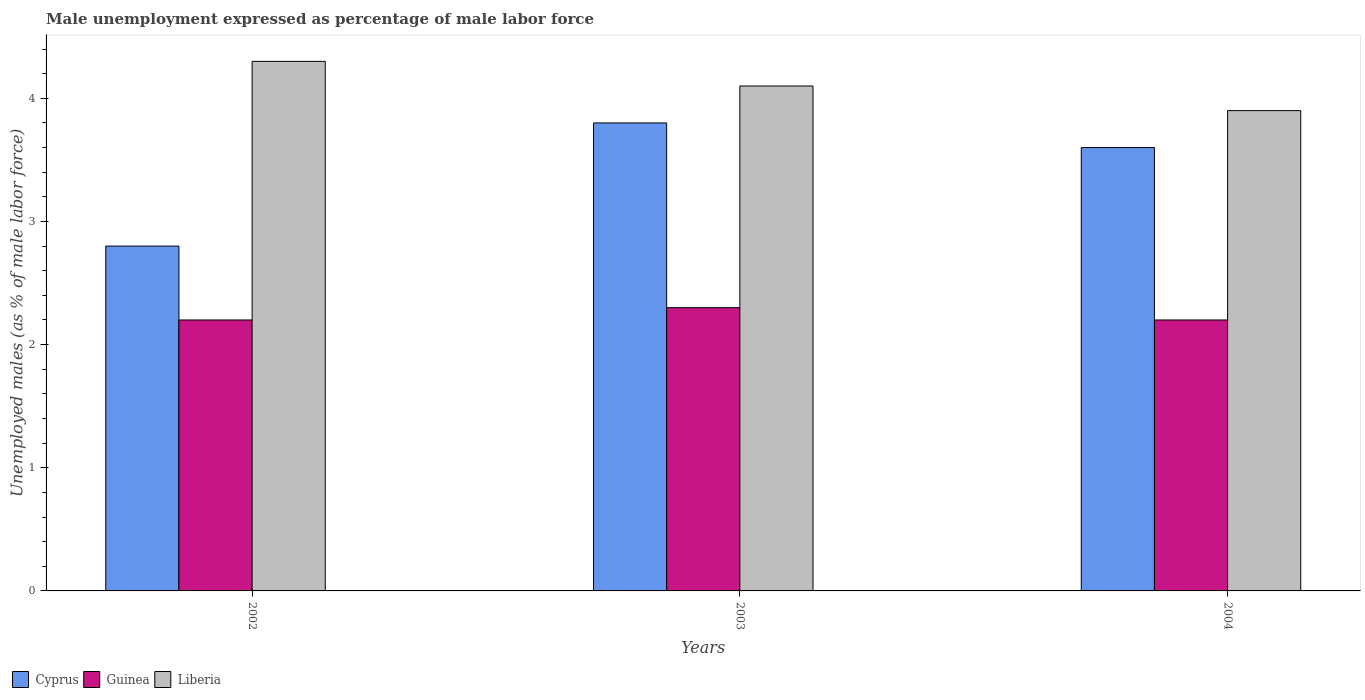How many different coloured bars are there?
Make the answer very short. 3. Are the number of bars per tick equal to the number of legend labels?
Provide a succinct answer. Yes. Are the number of bars on each tick of the X-axis equal?
Offer a very short reply. Yes. What is the unemployment in males in in Liberia in 2004?
Offer a very short reply. 3.9. Across all years, what is the maximum unemployment in males in in Liberia?
Keep it short and to the point. 4.3. Across all years, what is the minimum unemployment in males in in Guinea?
Ensure brevity in your answer.  2.2. In which year was the unemployment in males in in Guinea maximum?
Offer a very short reply. 2003. What is the total unemployment in males in in Liberia in the graph?
Offer a terse response. 12.3. What is the difference between the unemployment in males in in Liberia in 2002 and that in 2003?
Offer a very short reply. 0.2. What is the difference between the unemployment in males in in Liberia in 2002 and the unemployment in males in in Guinea in 2004?
Provide a succinct answer. 2.1. What is the average unemployment in males in in Liberia per year?
Your response must be concise. 4.1. In the year 2004, what is the difference between the unemployment in males in in Liberia and unemployment in males in in Cyprus?
Provide a succinct answer. 0.3. What is the ratio of the unemployment in males in in Cyprus in 2002 to that in 2003?
Provide a succinct answer. 0.74. Is the unemployment in males in in Cyprus in 2002 less than that in 2004?
Ensure brevity in your answer.  Yes. Is the difference between the unemployment in males in in Liberia in 2002 and 2003 greater than the difference between the unemployment in males in in Cyprus in 2002 and 2003?
Offer a terse response. Yes. What is the difference between the highest and the second highest unemployment in males in in Cyprus?
Keep it short and to the point. 0.2. What is the difference between the highest and the lowest unemployment in males in in Cyprus?
Make the answer very short. 1. In how many years, is the unemployment in males in in Liberia greater than the average unemployment in males in in Liberia taken over all years?
Your answer should be very brief. 1. Is the sum of the unemployment in males in in Guinea in 2003 and 2004 greater than the maximum unemployment in males in in Liberia across all years?
Ensure brevity in your answer.  Yes. What does the 1st bar from the left in 2003 represents?
Offer a terse response. Cyprus. What does the 3rd bar from the right in 2004 represents?
Give a very brief answer. Cyprus. How many years are there in the graph?
Your answer should be compact. 3. Does the graph contain grids?
Give a very brief answer. No. What is the title of the graph?
Make the answer very short. Male unemployment expressed as percentage of male labor force. Does "Argentina" appear as one of the legend labels in the graph?
Offer a very short reply. No. What is the label or title of the X-axis?
Your answer should be compact. Years. What is the label or title of the Y-axis?
Ensure brevity in your answer.  Unemployed males (as % of male labor force). What is the Unemployed males (as % of male labor force) of Cyprus in 2002?
Ensure brevity in your answer.  2.8. What is the Unemployed males (as % of male labor force) in Guinea in 2002?
Ensure brevity in your answer.  2.2. What is the Unemployed males (as % of male labor force) in Liberia in 2002?
Provide a succinct answer. 4.3. What is the Unemployed males (as % of male labor force) of Cyprus in 2003?
Provide a short and direct response. 3.8. What is the Unemployed males (as % of male labor force) in Guinea in 2003?
Your response must be concise. 2.3. What is the Unemployed males (as % of male labor force) in Liberia in 2003?
Ensure brevity in your answer.  4.1. What is the Unemployed males (as % of male labor force) in Cyprus in 2004?
Provide a short and direct response. 3.6. What is the Unemployed males (as % of male labor force) of Guinea in 2004?
Provide a succinct answer. 2.2. What is the Unemployed males (as % of male labor force) of Liberia in 2004?
Provide a succinct answer. 3.9. Across all years, what is the maximum Unemployed males (as % of male labor force) in Cyprus?
Give a very brief answer. 3.8. Across all years, what is the maximum Unemployed males (as % of male labor force) in Guinea?
Provide a succinct answer. 2.3. Across all years, what is the maximum Unemployed males (as % of male labor force) of Liberia?
Keep it short and to the point. 4.3. Across all years, what is the minimum Unemployed males (as % of male labor force) of Cyprus?
Provide a succinct answer. 2.8. Across all years, what is the minimum Unemployed males (as % of male labor force) of Guinea?
Your answer should be very brief. 2.2. Across all years, what is the minimum Unemployed males (as % of male labor force) in Liberia?
Keep it short and to the point. 3.9. What is the total Unemployed males (as % of male labor force) of Cyprus in the graph?
Ensure brevity in your answer.  10.2. What is the total Unemployed males (as % of male labor force) of Liberia in the graph?
Offer a very short reply. 12.3. What is the difference between the Unemployed males (as % of male labor force) in Cyprus in 2002 and that in 2003?
Your answer should be very brief. -1. What is the difference between the Unemployed males (as % of male labor force) of Guinea in 2002 and that in 2003?
Provide a succinct answer. -0.1. What is the difference between the Unemployed males (as % of male labor force) of Liberia in 2002 and that in 2003?
Make the answer very short. 0.2. What is the difference between the Unemployed males (as % of male labor force) of Guinea in 2002 and that in 2004?
Provide a short and direct response. 0. What is the difference between the Unemployed males (as % of male labor force) of Liberia in 2002 and that in 2004?
Give a very brief answer. 0.4. What is the difference between the Unemployed males (as % of male labor force) of Cyprus in 2003 and that in 2004?
Ensure brevity in your answer.  0.2. What is the difference between the Unemployed males (as % of male labor force) of Guinea in 2003 and that in 2004?
Offer a terse response. 0.1. What is the difference between the Unemployed males (as % of male labor force) in Cyprus in 2002 and the Unemployed males (as % of male labor force) in Guinea in 2003?
Your answer should be very brief. 0.5. What is the difference between the Unemployed males (as % of male labor force) of Cyprus in 2002 and the Unemployed males (as % of male labor force) of Liberia in 2003?
Your answer should be compact. -1.3. What is the difference between the Unemployed males (as % of male labor force) of Guinea in 2002 and the Unemployed males (as % of male labor force) of Liberia in 2003?
Your answer should be compact. -1.9. What is the difference between the Unemployed males (as % of male labor force) of Cyprus in 2002 and the Unemployed males (as % of male labor force) of Liberia in 2004?
Your response must be concise. -1.1. What is the difference between the Unemployed males (as % of male labor force) in Guinea in 2002 and the Unemployed males (as % of male labor force) in Liberia in 2004?
Make the answer very short. -1.7. What is the difference between the Unemployed males (as % of male labor force) in Cyprus in 2003 and the Unemployed males (as % of male labor force) in Guinea in 2004?
Your answer should be compact. 1.6. What is the difference between the Unemployed males (as % of male labor force) of Cyprus in 2003 and the Unemployed males (as % of male labor force) of Liberia in 2004?
Make the answer very short. -0.1. What is the difference between the Unemployed males (as % of male labor force) of Guinea in 2003 and the Unemployed males (as % of male labor force) of Liberia in 2004?
Provide a succinct answer. -1.6. What is the average Unemployed males (as % of male labor force) of Cyprus per year?
Your answer should be compact. 3.4. What is the average Unemployed males (as % of male labor force) in Guinea per year?
Offer a very short reply. 2.23. In the year 2002, what is the difference between the Unemployed males (as % of male labor force) in Cyprus and Unemployed males (as % of male labor force) in Guinea?
Ensure brevity in your answer.  0.6. In the year 2002, what is the difference between the Unemployed males (as % of male labor force) in Cyprus and Unemployed males (as % of male labor force) in Liberia?
Keep it short and to the point. -1.5. In the year 2003, what is the difference between the Unemployed males (as % of male labor force) in Cyprus and Unemployed males (as % of male labor force) in Guinea?
Provide a succinct answer. 1.5. In the year 2003, what is the difference between the Unemployed males (as % of male labor force) of Cyprus and Unemployed males (as % of male labor force) of Liberia?
Make the answer very short. -0.3. In the year 2004, what is the difference between the Unemployed males (as % of male labor force) of Guinea and Unemployed males (as % of male labor force) of Liberia?
Provide a short and direct response. -1.7. What is the ratio of the Unemployed males (as % of male labor force) of Cyprus in 2002 to that in 2003?
Your answer should be very brief. 0.74. What is the ratio of the Unemployed males (as % of male labor force) of Guinea in 2002 to that in 2003?
Give a very brief answer. 0.96. What is the ratio of the Unemployed males (as % of male labor force) of Liberia in 2002 to that in 2003?
Offer a terse response. 1.05. What is the ratio of the Unemployed males (as % of male labor force) in Cyprus in 2002 to that in 2004?
Provide a succinct answer. 0.78. What is the ratio of the Unemployed males (as % of male labor force) of Guinea in 2002 to that in 2004?
Ensure brevity in your answer.  1. What is the ratio of the Unemployed males (as % of male labor force) of Liberia in 2002 to that in 2004?
Provide a short and direct response. 1.1. What is the ratio of the Unemployed males (as % of male labor force) in Cyprus in 2003 to that in 2004?
Ensure brevity in your answer.  1.06. What is the ratio of the Unemployed males (as % of male labor force) in Guinea in 2003 to that in 2004?
Make the answer very short. 1.05. What is the ratio of the Unemployed males (as % of male labor force) of Liberia in 2003 to that in 2004?
Provide a succinct answer. 1.05. 